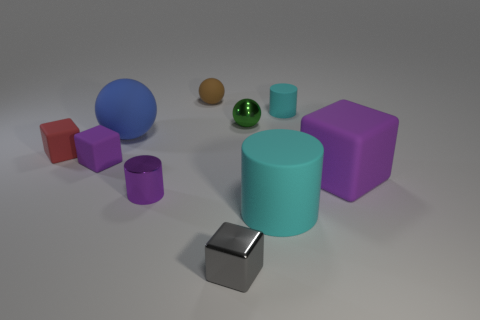What number of objects are either cyan objects that are in front of the red block or tiny things behind the small metallic cube?
Offer a very short reply. 7. Are there any other things that have the same shape as the small gray thing?
Your answer should be very brief. Yes. What material is the small cylinder that is the same color as the big block?
Provide a short and direct response. Metal. What number of metal things are cyan cylinders or small purple cylinders?
Ensure brevity in your answer.  1. The blue object has what shape?
Give a very brief answer. Sphere. How many large blue balls have the same material as the big cyan cylinder?
Offer a very short reply. 1. The tiny cylinder that is made of the same material as the tiny brown ball is what color?
Give a very brief answer. Cyan. There is a purple block that is left of the blue rubber ball; does it have the same size as the brown sphere?
Ensure brevity in your answer.  Yes. There is another small metal object that is the same shape as the red object; what is its color?
Your answer should be very brief. Gray. What shape is the small metallic thing that is in front of the matte cylinder in front of the cyan matte object that is behind the red rubber cube?
Your response must be concise. Cube. 